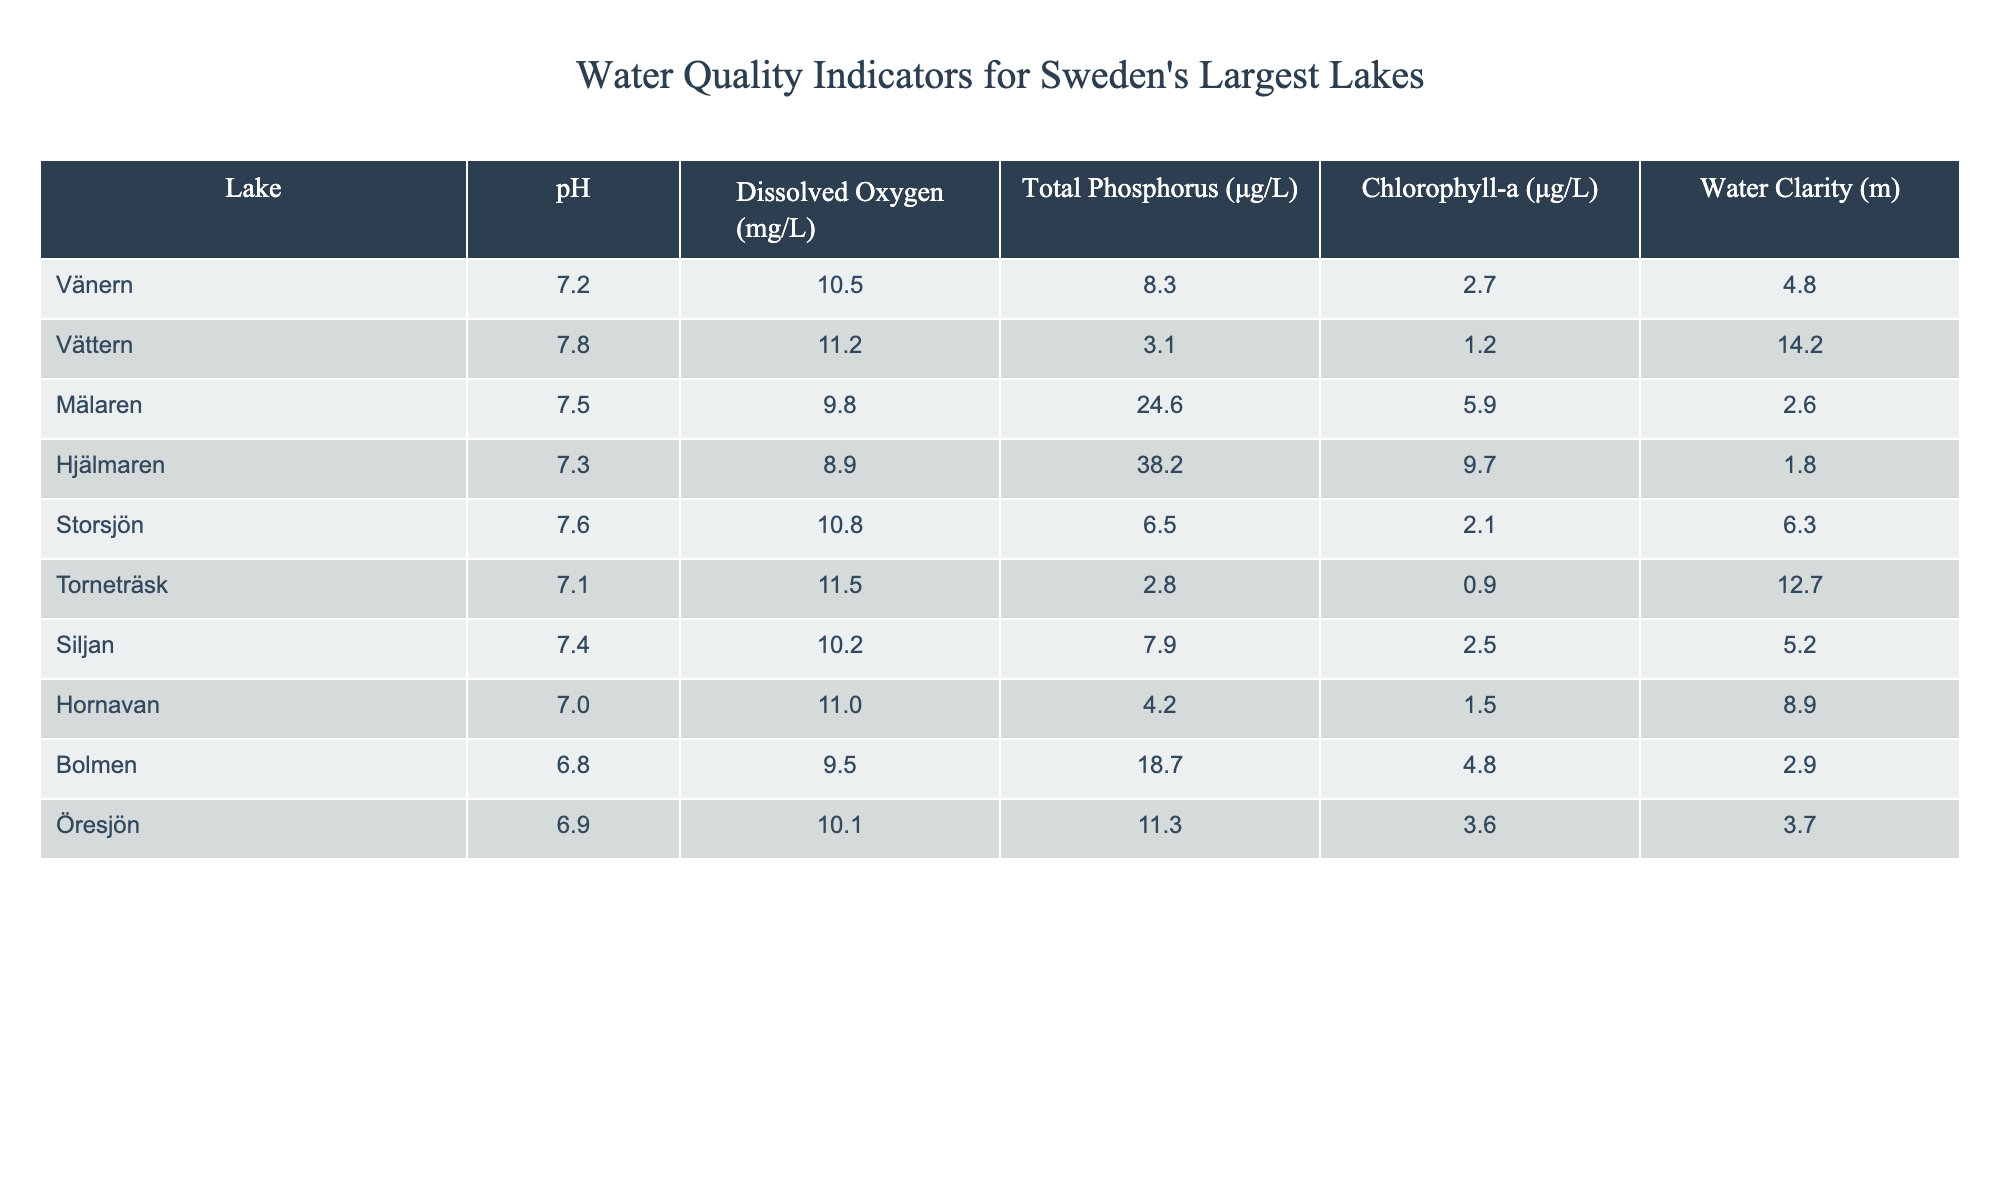What is the pH level of Lake Vättern? The table lists the pH levels for each lake. Looking at Lake Vättern, the pH level is stated directly as 7.8.
Answer: 7.8 Which lake has the highest dissolved oxygen concentration? In the table, the dissolved oxygen levels are listed for each lake. By comparing them, Torneträsk has the highest value at 11.5 mg/L.
Answer: Torneträsk What is the total phosphorus level in Lake Mälaren? The table indicates that Lake Mälaren has a total phosphorus level of 24.6 μg/L.
Answer: 24.6 μg/L Is the water clarity of Lake Hjälmaren greater than that of Lake Bolmen? The table displays the water clarity for both lakes: Hjälmaren has 1.8 m while Bolmen has 2.9 m. Since 1.8 < 2.9, the statement is false.
Answer: No What is the average chlorophyll-a concentration for the lakes listed in the table? To find the average, sum the chlorophyll-a values: (2.7 + 1.2 + 5.9 + 9.7 + 2.1 + 0.9 + 2.5 + 1.5 + 4.8 + 3.6) = 32.9 μg/L. There are 10 lakes, so the average is 32.9/10 = 3.29 μg/L.
Answer: 3.29 μg/L Which lake shows the lowest total phosphorus level? Looking at the total phosphorus column in the table, the minimum value is 2.8 μg/L found in Lake Torneträsk.
Answer: Torneträsk Is the average pH level of all the lakes greater than 7.5? First, calculate the average pH value: (7.2 + 7.8 + 7.5 + 7.3 + 7.6 + 7.1 + 7.4 + 7.0 + 6.8 + 6.9) = 74.6. Then divide by 10 to find the average: 74.6/10 = 7.46. Since 7.46 < 7.5, the answer is false.
Answer: No Which lake has both the highest water clarity and the lowest phosphorous level? Checking the water clarity and phosphorus levels, Lake Vättern ranks the highest in water clarity at 14.2 m and has a low phosphorus level of 3.1 μg/L, meeting both criteria.
Answer: Lake Vättern How do the dissolved oxygen levels of Storsjön and Hjälmaren compare? Storsjön has 10.8 mg/L and Hjälmaren has 8.9 mg/L. Storsjön's level is higher than Hjälmaren’s.
Answer: Storsjön is higher What is the difference in Total Phosphorus levels between Mälaren and Vättern? Mälaren has 24.6 μg/L and Vättern has 3.1 μg/L. The difference is 24.6 - 3.1 = 21.5 μg/L.
Answer: 21.5 μg/L 